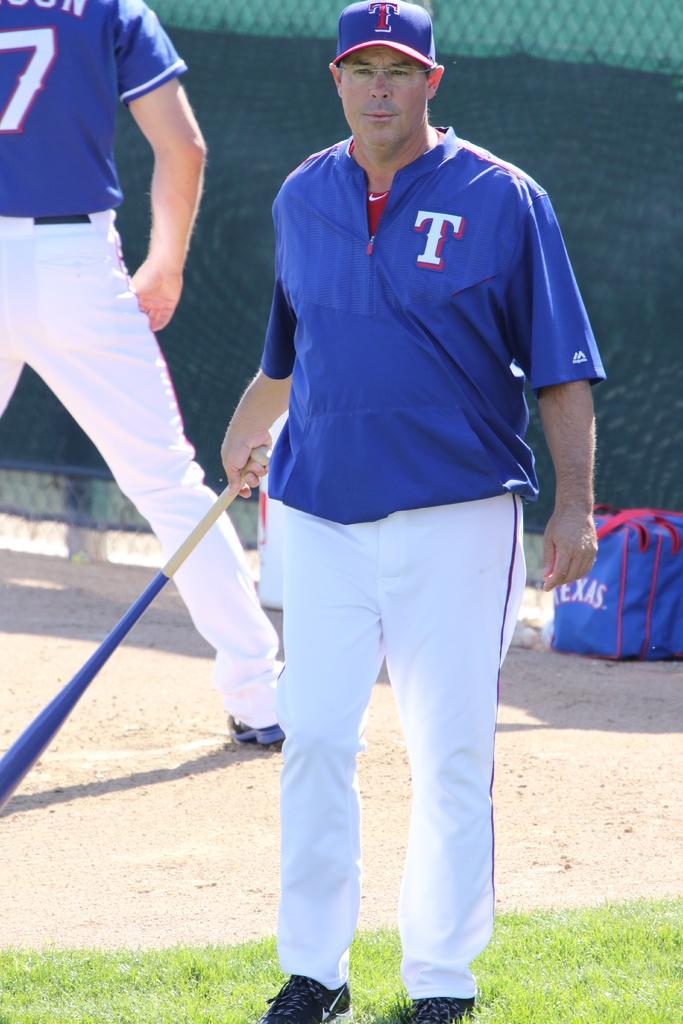What is the number on the person's back?
Offer a terse response. 7. 